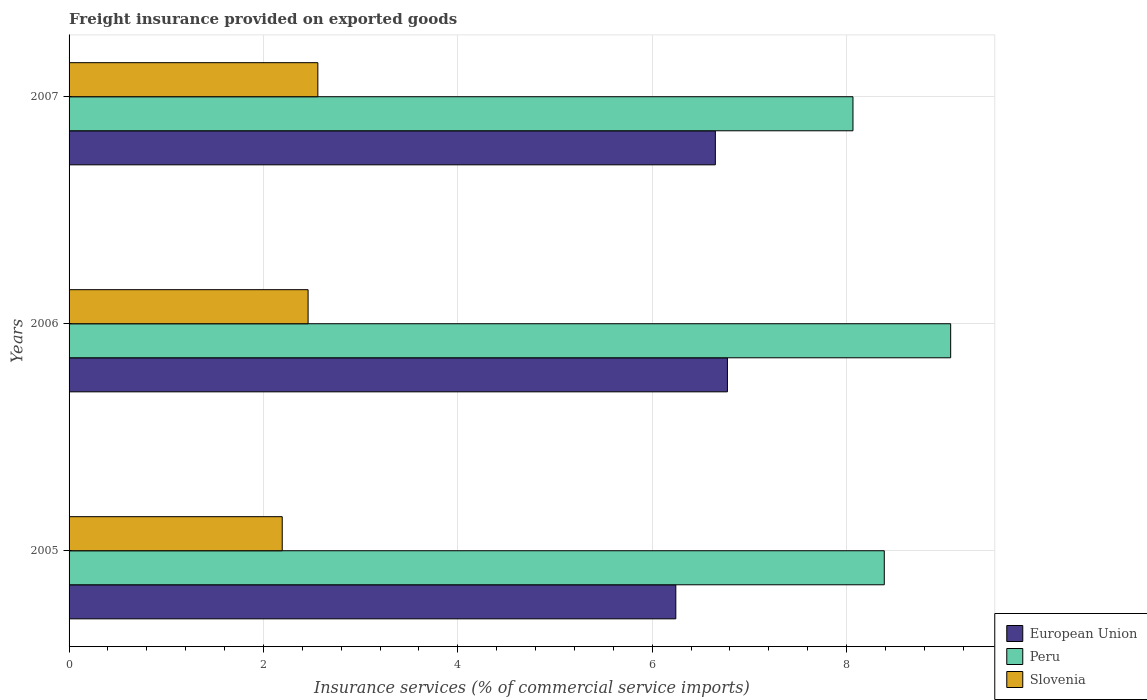Are the number of bars per tick equal to the number of legend labels?
Your response must be concise. Yes. Are the number of bars on each tick of the Y-axis equal?
Ensure brevity in your answer.  Yes. How many bars are there on the 2nd tick from the bottom?
Provide a short and direct response. 3. What is the label of the 3rd group of bars from the top?
Make the answer very short. 2005. In how many cases, is the number of bars for a given year not equal to the number of legend labels?
Provide a short and direct response. 0. What is the freight insurance provided on exported goods in European Union in 2005?
Your answer should be very brief. 6.24. Across all years, what is the maximum freight insurance provided on exported goods in Peru?
Offer a very short reply. 9.07. Across all years, what is the minimum freight insurance provided on exported goods in European Union?
Provide a short and direct response. 6.24. In which year was the freight insurance provided on exported goods in Peru maximum?
Offer a terse response. 2006. In which year was the freight insurance provided on exported goods in European Union minimum?
Keep it short and to the point. 2005. What is the total freight insurance provided on exported goods in Slovenia in the graph?
Ensure brevity in your answer.  7.21. What is the difference between the freight insurance provided on exported goods in Slovenia in 2005 and that in 2006?
Make the answer very short. -0.27. What is the difference between the freight insurance provided on exported goods in Peru in 2006 and the freight insurance provided on exported goods in European Union in 2005?
Provide a short and direct response. 2.83. What is the average freight insurance provided on exported goods in Slovenia per year?
Offer a terse response. 2.4. In the year 2005, what is the difference between the freight insurance provided on exported goods in Slovenia and freight insurance provided on exported goods in Peru?
Make the answer very short. -6.2. What is the ratio of the freight insurance provided on exported goods in Peru in 2005 to that in 2006?
Provide a short and direct response. 0.92. What is the difference between the highest and the second highest freight insurance provided on exported goods in European Union?
Offer a terse response. 0.12. What is the difference between the highest and the lowest freight insurance provided on exported goods in European Union?
Offer a terse response. 0.53. What does the 3rd bar from the bottom in 2006 represents?
Provide a succinct answer. Slovenia. Are all the bars in the graph horizontal?
Your response must be concise. Yes. What is the difference between two consecutive major ticks on the X-axis?
Provide a short and direct response. 2. Are the values on the major ticks of X-axis written in scientific E-notation?
Your answer should be very brief. No. Does the graph contain any zero values?
Your response must be concise. No. Does the graph contain grids?
Make the answer very short. Yes. How are the legend labels stacked?
Your answer should be compact. Vertical. What is the title of the graph?
Keep it short and to the point. Freight insurance provided on exported goods. Does "Finland" appear as one of the legend labels in the graph?
Make the answer very short. No. What is the label or title of the X-axis?
Your response must be concise. Insurance services (% of commercial service imports). What is the label or title of the Y-axis?
Make the answer very short. Years. What is the Insurance services (% of commercial service imports) of European Union in 2005?
Give a very brief answer. 6.24. What is the Insurance services (% of commercial service imports) in Peru in 2005?
Provide a succinct answer. 8.39. What is the Insurance services (% of commercial service imports) of Slovenia in 2005?
Ensure brevity in your answer.  2.19. What is the Insurance services (% of commercial service imports) of European Union in 2006?
Your answer should be very brief. 6.77. What is the Insurance services (% of commercial service imports) in Peru in 2006?
Make the answer very short. 9.07. What is the Insurance services (% of commercial service imports) of Slovenia in 2006?
Keep it short and to the point. 2.46. What is the Insurance services (% of commercial service imports) of European Union in 2007?
Your response must be concise. 6.65. What is the Insurance services (% of commercial service imports) of Peru in 2007?
Your answer should be very brief. 8.07. What is the Insurance services (% of commercial service imports) in Slovenia in 2007?
Provide a succinct answer. 2.56. Across all years, what is the maximum Insurance services (% of commercial service imports) in European Union?
Give a very brief answer. 6.77. Across all years, what is the maximum Insurance services (% of commercial service imports) in Peru?
Keep it short and to the point. 9.07. Across all years, what is the maximum Insurance services (% of commercial service imports) in Slovenia?
Your answer should be compact. 2.56. Across all years, what is the minimum Insurance services (% of commercial service imports) in European Union?
Keep it short and to the point. 6.24. Across all years, what is the minimum Insurance services (% of commercial service imports) of Peru?
Offer a very short reply. 8.07. Across all years, what is the minimum Insurance services (% of commercial service imports) of Slovenia?
Give a very brief answer. 2.19. What is the total Insurance services (% of commercial service imports) in European Union in the graph?
Offer a very short reply. 19.67. What is the total Insurance services (% of commercial service imports) in Peru in the graph?
Provide a short and direct response. 25.53. What is the total Insurance services (% of commercial service imports) in Slovenia in the graph?
Keep it short and to the point. 7.21. What is the difference between the Insurance services (% of commercial service imports) in European Union in 2005 and that in 2006?
Your answer should be very brief. -0.53. What is the difference between the Insurance services (% of commercial service imports) in Peru in 2005 and that in 2006?
Your answer should be compact. -0.68. What is the difference between the Insurance services (% of commercial service imports) of Slovenia in 2005 and that in 2006?
Offer a very short reply. -0.27. What is the difference between the Insurance services (% of commercial service imports) in European Union in 2005 and that in 2007?
Your answer should be very brief. -0.41. What is the difference between the Insurance services (% of commercial service imports) in Peru in 2005 and that in 2007?
Offer a very short reply. 0.32. What is the difference between the Insurance services (% of commercial service imports) in Slovenia in 2005 and that in 2007?
Your answer should be very brief. -0.37. What is the difference between the Insurance services (% of commercial service imports) in European Union in 2006 and that in 2007?
Your answer should be very brief. 0.12. What is the difference between the Insurance services (% of commercial service imports) in Peru in 2006 and that in 2007?
Provide a short and direct response. 1.01. What is the difference between the Insurance services (% of commercial service imports) of Slovenia in 2006 and that in 2007?
Ensure brevity in your answer.  -0.1. What is the difference between the Insurance services (% of commercial service imports) of European Union in 2005 and the Insurance services (% of commercial service imports) of Peru in 2006?
Keep it short and to the point. -2.83. What is the difference between the Insurance services (% of commercial service imports) in European Union in 2005 and the Insurance services (% of commercial service imports) in Slovenia in 2006?
Your answer should be compact. 3.78. What is the difference between the Insurance services (% of commercial service imports) of Peru in 2005 and the Insurance services (% of commercial service imports) of Slovenia in 2006?
Your answer should be compact. 5.93. What is the difference between the Insurance services (% of commercial service imports) in European Union in 2005 and the Insurance services (% of commercial service imports) in Peru in 2007?
Your answer should be compact. -1.82. What is the difference between the Insurance services (% of commercial service imports) in European Union in 2005 and the Insurance services (% of commercial service imports) in Slovenia in 2007?
Make the answer very short. 3.68. What is the difference between the Insurance services (% of commercial service imports) of Peru in 2005 and the Insurance services (% of commercial service imports) of Slovenia in 2007?
Offer a very short reply. 5.83. What is the difference between the Insurance services (% of commercial service imports) of European Union in 2006 and the Insurance services (% of commercial service imports) of Peru in 2007?
Your answer should be compact. -1.29. What is the difference between the Insurance services (% of commercial service imports) of European Union in 2006 and the Insurance services (% of commercial service imports) of Slovenia in 2007?
Offer a very short reply. 4.21. What is the difference between the Insurance services (% of commercial service imports) in Peru in 2006 and the Insurance services (% of commercial service imports) in Slovenia in 2007?
Offer a very short reply. 6.51. What is the average Insurance services (% of commercial service imports) in European Union per year?
Your answer should be very brief. 6.56. What is the average Insurance services (% of commercial service imports) of Peru per year?
Ensure brevity in your answer.  8.51. What is the average Insurance services (% of commercial service imports) of Slovenia per year?
Your answer should be very brief. 2.4. In the year 2005, what is the difference between the Insurance services (% of commercial service imports) of European Union and Insurance services (% of commercial service imports) of Peru?
Keep it short and to the point. -2.15. In the year 2005, what is the difference between the Insurance services (% of commercial service imports) in European Union and Insurance services (% of commercial service imports) in Slovenia?
Offer a terse response. 4.05. In the year 2005, what is the difference between the Insurance services (% of commercial service imports) in Peru and Insurance services (% of commercial service imports) in Slovenia?
Provide a succinct answer. 6.2. In the year 2006, what is the difference between the Insurance services (% of commercial service imports) of European Union and Insurance services (% of commercial service imports) of Peru?
Provide a succinct answer. -2.3. In the year 2006, what is the difference between the Insurance services (% of commercial service imports) of European Union and Insurance services (% of commercial service imports) of Slovenia?
Provide a succinct answer. 4.32. In the year 2006, what is the difference between the Insurance services (% of commercial service imports) in Peru and Insurance services (% of commercial service imports) in Slovenia?
Make the answer very short. 6.61. In the year 2007, what is the difference between the Insurance services (% of commercial service imports) of European Union and Insurance services (% of commercial service imports) of Peru?
Provide a short and direct response. -1.42. In the year 2007, what is the difference between the Insurance services (% of commercial service imports) in European Union and Insurance services (% of commercial service imports) in Slovenia?
Offer a very short reply. 4.09. In the year 2007, what is the difference between the Insurance services (% of commercial service imports) in Peru and Insurance services (% of commercial service imports) in Slovenia?
Provide a succinct answer. 5.51. What is the ratio of the Insurance services (% of commercial service imports) in European Union in 2005 to that in 2006?
Provide a succinct answer. 0.92. What is the ratio of the Insurance services (% of commercial service imports) of Peru in 2005 to that in 2006?
Provide a short and direct response. 0.92. What is the ratio of the Insurance services (% of commercial service imports) in Slovenia in 2005 to that in 2006?
Provide a short and direct response. 0.89. What is the ratio of the Insurance services (% of commercial service imports) of European Union in 2005 to that in 2007?
Offer a very short reply. 0.94. What is the ratio of the Insurance services (% of commercial service imports) of Peru in 2005 to that in 2007?
Provide a succinct answer. 1.04. What is the ratio of the Insurance services (% of commercial service imports) in Slovenia in 2005 to that in 2007?
Offer a terse response. 0.86. What is the ratio of the Insurance services (% of commercial service imports) of European Union in 2006 to that in 2007?
Ensure brevity in your answer.  1.02. What is the ratio of the Insurance services (% of commercial service imports) in Peru in 2006 to that in 2007?
Offer a terse response. 1.12. What is the ratio of the Insurance services (% of commercial service imports) in Slovenia in 2006 to that in 2007?
Your answer should be very brief. 0.96. What is the difference between the highest and the second highest Insurance services (% of commercial service imports) of European Union?
Your answer should be compact. 0.12. What is the difference between the highest and the second highest Insurance services (% of commercial service imports) in Peru?
Your response must be concise. 0.68. What is the difference between the highest and the second highest Insurance services (% of commercial service imports) in Slovenia?
Offer a very short reply. 0.1. What is the difference between the highest and the lowest Insurance services (% of commercial service imports) in European Union?
Your response must be concise. 0.53. What is the difference between the highest and the lowest Insurance services (% of commercial service imports) of Peru?
Offer a very short reply. 1.01. What is the difference between the highest and the lowest Insurance services (% of commercial service imports) of Slovenia?
Keep it short and to the point. 0.37. 